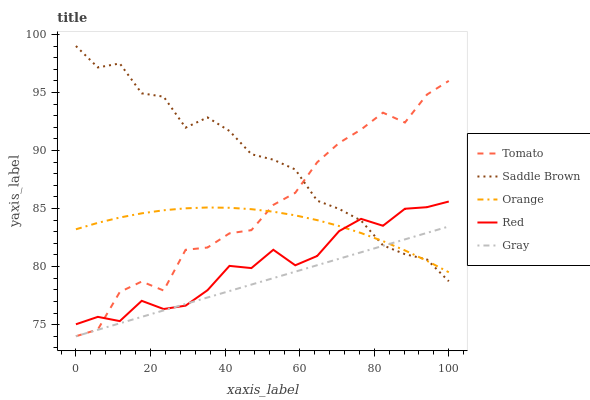Does Orange have the minimum area under the curve?
Answer yes or no. No. Does Orange have the maximum area under the curve?
Answer yes or no. No. Is Orange the smoothest?
Answer yes or no. No. Is Orange the roughest?
Answer yes or no. No. Does Saddle Brown have the lowest value?
Answer yes or no. No. Does Orange have the highest value?
Answer yes or no. No. 